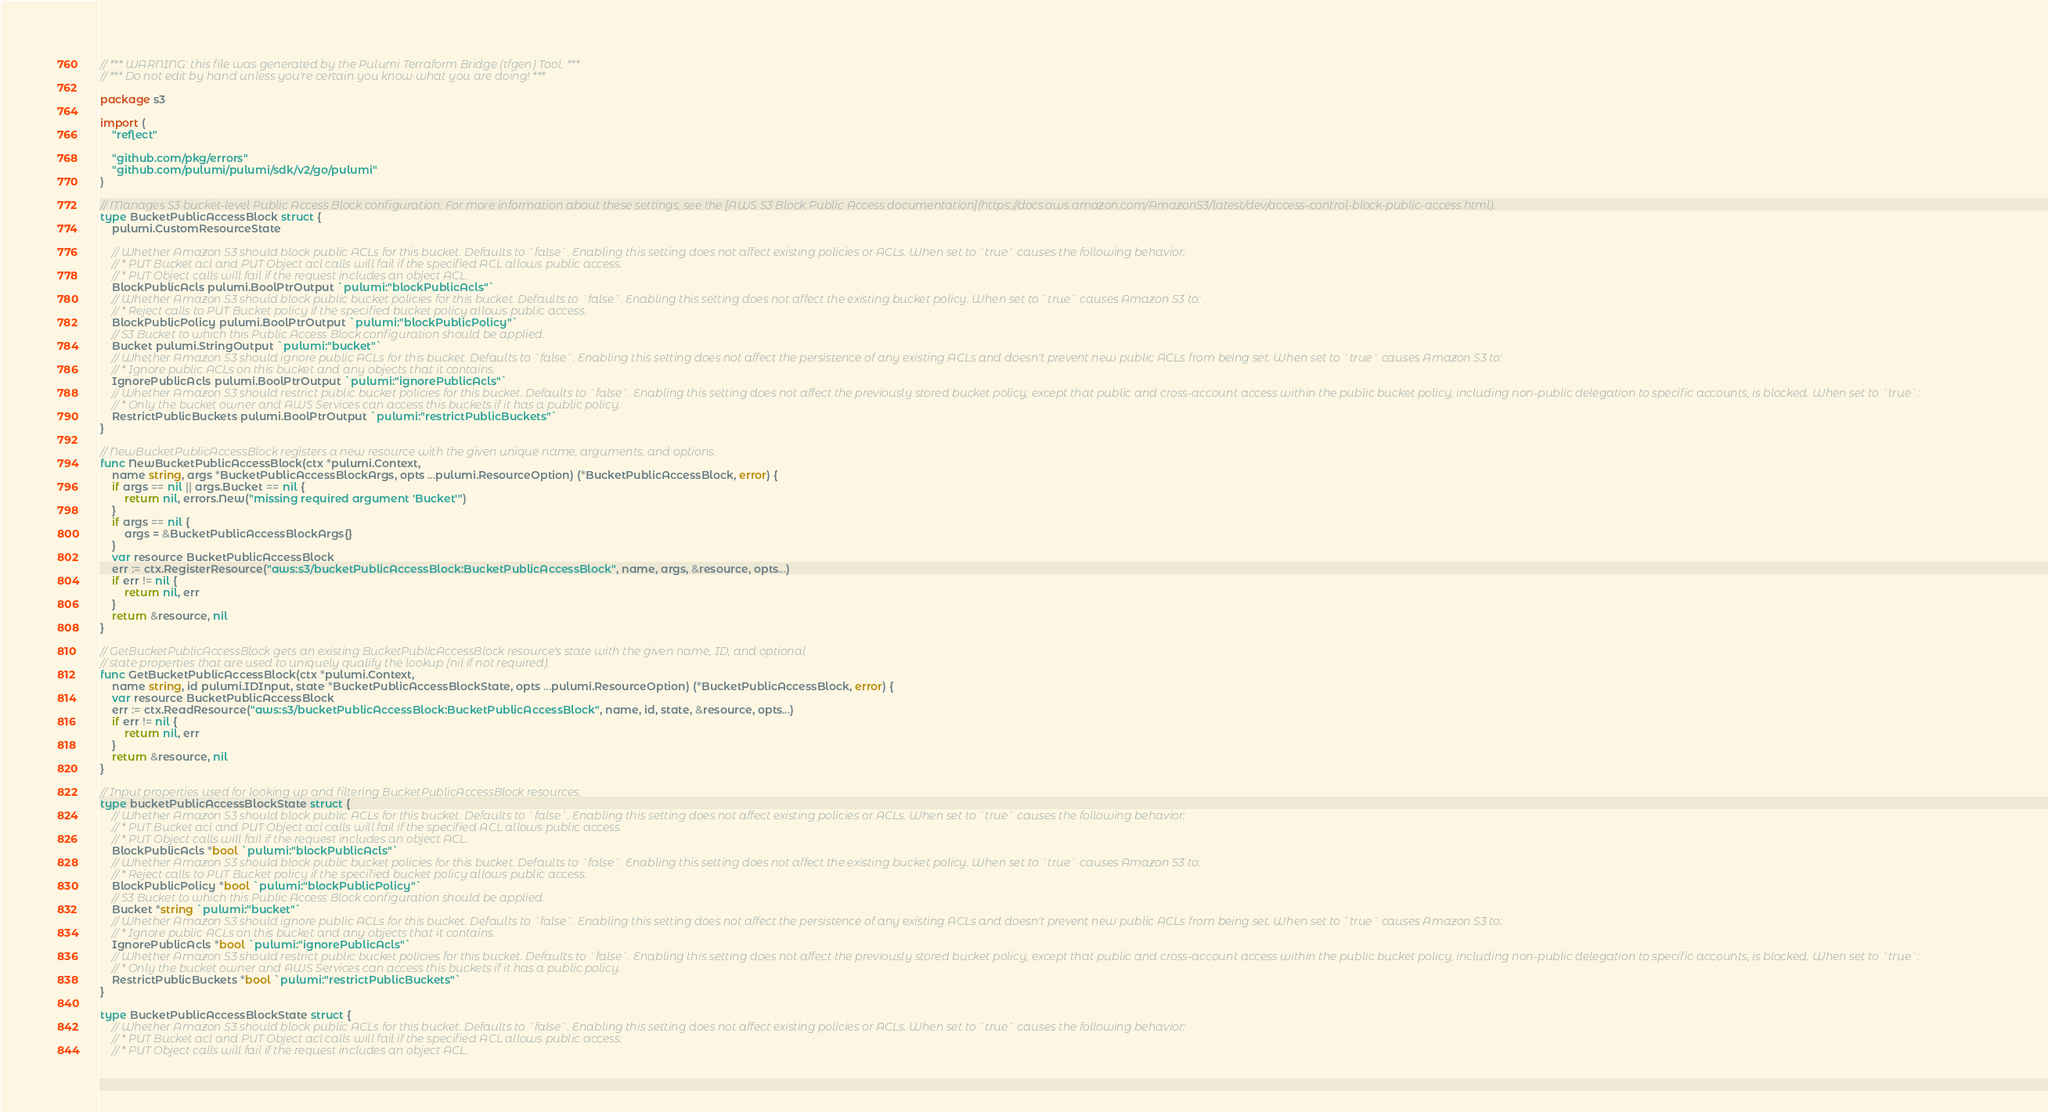<code> <loc_0><loc_0><loc_500><loc_500><_Go_>// *** WARNING: this file was generated by the Pulumi Terraform Bridge (tfgen) Tool. ***
// *** Do not edit by hand unless you're certain you know what you are doing! ***

package s3

import (
	"reflect"

	"github.com/pkg/errors"
	"github.com/pulumi/pulumi/sdk/v2/go/pulumi"
)

// Manages S3 bucket-level Public Access Block configuration. For more information about these settings, see the [AWS S3 Block Public Access documentation](https://docs.aws.amazon.com/AmazonS3/latest/dev/access-control-block-public-access.html).
type BucketPublicAccessBlock struct {
	pulumi.CustomResourceState

	// Whether Amazon S3 should block public ACLs for this bucket. Defaults to `false`. Enabling this setting does not affect existing policies or ACLs. When set to `true` causes the following behavior:
	// * PUT Bucket acl and PUT Object acl calls will fail if the specified ACL allows public access.
	// * PUT Object calls will fail if the request includes an object ACL.
	BlockPublicAcls pulumi.BoolPtrOutput `pulumi:"blockPublicAcls"`
	// Whether Amazon S3 should block public bucket policies for this bucket. Defaults to `false`. Enabling this setting does not affect the existing bucket policy. When set to `true` causes Amazon S3 to:
	// * Reject calls to PUT Bucket policy if the specified bucket policy allows public access.
	BlockPublicPolicy pulumi.BoolPtrOutput `pulumi:"blockPublicPolicy"`
	// S3 Bucket to which this Public Access Block configuration should be applied.
	Bucket pulumi.StringOutput `pulumi:"bucket"`
	// Whether Amazon S3 should ignore public ACLs for this bucket. Defaults to `false`. Enabling this setting does not affect the persistence of any existing ACLs and doesn't prevent new public ACLs from being set. When set to `true` causes Amazon S3 to:
	// * Ignore public ACLs on this bucket and any objects that it contains.
	IgnorePublicAcls pulumi.BoolPtrOutput `pulumi:"ignorePublicAcls"`
	// Whether Amazon S3 should restrict public bucket policies for this bucket. Defaults to `false`. Enabling this setting does not affect the previously stored bucket policy, except that public and cross-account access within the public bucket policy, including non-public delegation to specific accounts, is blocked. When set to `true`:
	// * Only the bucket owner and AWS Services can access this buckets if it has a public policy.
	RestrictPublicBuckets pulumi.BoolPtrOutput `pulumi:"restrictPublicBuckets"`
}

// NewBucketPublicAccessBlock registers a new resource with the given unique name, arguments, and options.
func NewBucketPublicAccessBlock(ctx *pulumi.Context,
	name string, args *BucketPublicAccessBlockArgs, opts ...pulumi.ResourceOption) (*BucketPublicAccessBlock, error) {
	if args == nil || args.Bucket == nil {
		return nil, errors.New("missing required argument 'Bucket'")
	}
	if args == nil {
		args = &BucketPublicAccessBlockArgs{}
	}
	var resource BucketPublicAccessBlock
	err := ctx.RegisterResource("aws:s3/bucketPublicAccessBlock:BucketPublicAccessBlock", name, args, &resource, opts...)
	if err != nil {
		return nil, err
	}
	return &resource, nil
}

// GetBucketPublicAccessBlock gets an existing BucketPublicAccessBlock resource's state with the given name, ID, and optional
// state properties that are used to uniquely qualify the lookup (nil if not required).
func GetBucketPublicAccessBlock(ctx *pulumi.Context,
	name string, id pulumi.IDInput, state *BucketPublicAccessBlockState, opts ...pulumi.ResourceOption) (*BucketPublicAccessBlock, error) {
	var resource BucketPublicAccessBlock
	err := ctx.ReadResource("aws:s3/bucketPublicAccessBlock:BucketPublicAccessBlock", name, id, state, &resource, opts...)
	if err != nil {
		return nil, err
	}
	return &resource, nil
}

// Input properties used for looking up and filtering BucketPublicAccessBlock resources.
type bucketPublicAccessBlockState struct {
	// Whether Amazon S3 should block public ACLs for this bucket. Defaults to `false`. Enabling this setting does not affect existing policies or ACLs. When set to `true` causes the following behavior:
	// * PUT Bucket acl and PUT Object acl calls will fail if the specified ACL allows public access.
	// * PUT Object calls will fail if the request includes an object ACL.
	BlockPublicAcls *bool `pulumi:"blockPublicAcls"`
	// Whether Amazon S3 should block public bucket policies for this bucket. Defaults to `false`. Enabling this setting does not affect the existing bucket policy. When set to `true` causes Amazon S3 to:
	// * Reject calls to PUT Bucket policy if the specified bucket policy allows public access.
	BlockPublicPolicy *bool `pulumi:"blockPublicPolicy"`
	// S3 Bucket to which this Public Access Block configuration should be applied.
	Bucket *string `pulumi:"bucket"`
	// Whether Amazon S3 should ignore public ACLs for this bucket. Defaults to `false`. Enabling this setting does not affect the persistence of any existing ACLs and doesn't prevent new public ACLs from being set. When set to `true` causes Amazon S3 to:
	// * Ignore public ACLs on this bucket and any objects that it contains.
	IgnorePublicAcls *bool `pulumi:"ignorePublicAcls"`
	// Whether Amazon S3 should restrict public bucket policies for this bucket. Defaults to `false`. Enabling this setting does not affect the previously stored bucket policy, except that public and cross-account access within the public bucket policy, including non-public delegation to specific accounts, is blocked. When set to `true`:
	// * Only the bucket owner and AWS Services can access this buckets if it has a public policy.
	RestrictPublicBuckets *bool `pulumi:"restrictPublicBuckets"`
}

type BucketPublicAccessBlockState struct {
	// Whether Amazon S3 should block public ACLs for this bucket. Defaults to `false`. Enabling this setting does not affect existing policies or ACLs. When set to `true` causes the following behavior:
	// * PUT Bucket acl and PUT Object acl calls will fail if the specified ACL allows public access.
	// * PUT Object calls will fail if the request includes an object ACL.</code> 